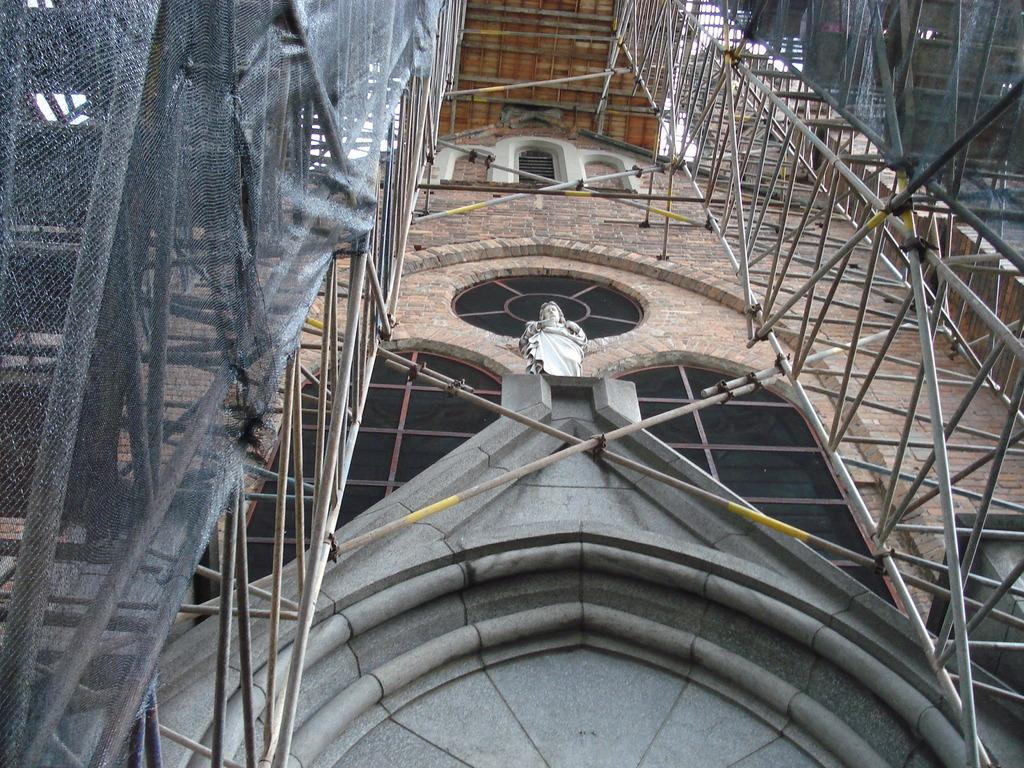What is the main subject of the image? The main subject of the image is a construction of a building. Is there any other prominent object or structure in the image? Yes, there is a statue in the middle of the image. What type of drink is being served at the top of the statue in the image? There is no drink or any indication of a drink being served in the image. 